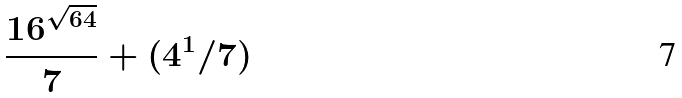<formula> <loc_0><loc_0><loc_500><loc_500>\frac { 1 6 ^ { \sqrt { 6 4 } } } { 7 } + ( 4 ^ { 1 } / 7 )</formula> 